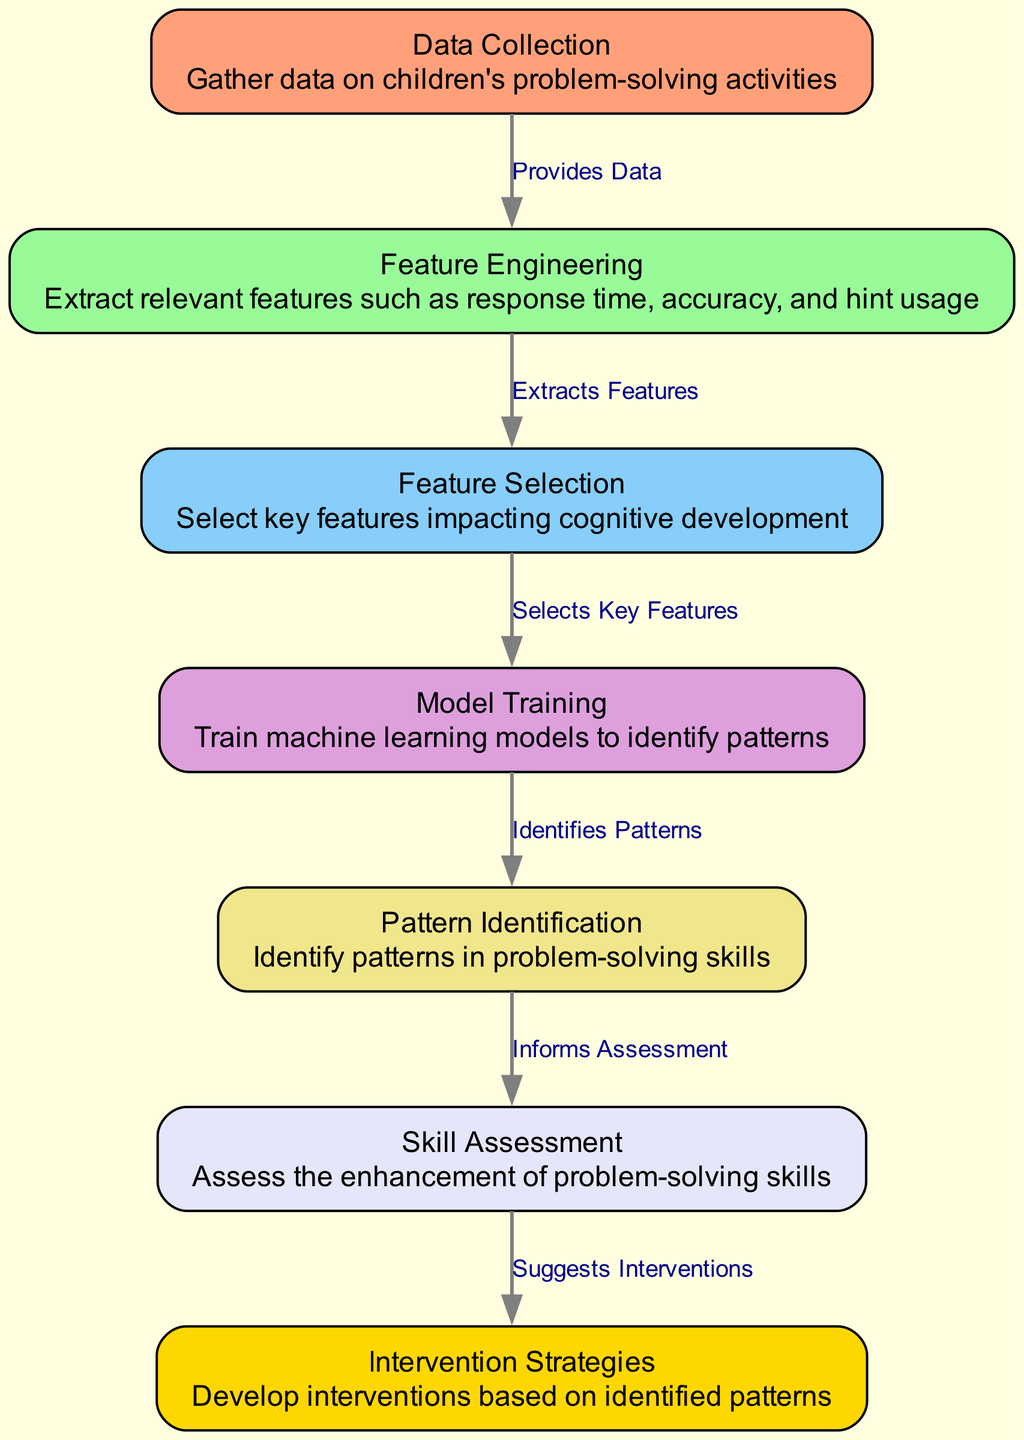What is the first step in the process? The first node in the diagram is "Data Collection," which indicates that the initial step is to gather data on children's problem-solving activities.
Answer: Data Collection How many nodes are there in total? By counting the nodes listed in the data, we see there are seven nodes representing different stages in the process.
Answer: 7 What does "Feature Engineering" do? "Feature Engineering" is responsible for extracting relevant features such as response time, accuracy, and hint usage, which is detailed in that node's description.
Answer: Extracts features Which node assesses the enhancement of problem-solving skills? The node labeled "Skill Assessment" is specifically responsible for assessing the enhancement of problem-solving skills, as indicated in its description.
Answer: Skill Assessment What connects "Model Training" to "Pattern Identification"? The edge between these nodes, which describes the relationship, states "Identifies Patterns," indicating that model training leads to the identification of patterns in children's problem-solving skills.
Answer: Identifies Patterns Which two nodes are directly connected without any other nodes in between? "Feature Selection" and "Model Training" are connected directly, as shown in the diagram, with the edge stating "Selects Key Features", meaning there's a direct relationship without any intervening nodes.
Answer: Feature Selection, Model Training How do the identified patterns inform assessments? The arrow connecting "Pattern Identification" and "Skill Assessment" shows that identified patterns in children's problem-solving skills directly inform the assessment process.
Answer: Informs Assessment What does the last step suggest? The last step is "Intervention Strategies," which suggests developing interventions based on the patterns identified in children's problem-solving skills enhancement.
Answer: Suggests Interventions What is the relationship between "Data Collection" and "Feature Engineering"? The edge between "Data Collection" and "Feature Engineering" indicates that the data gathered provides the necessary basis for extracting relevant features.
Answer: Provides Data 